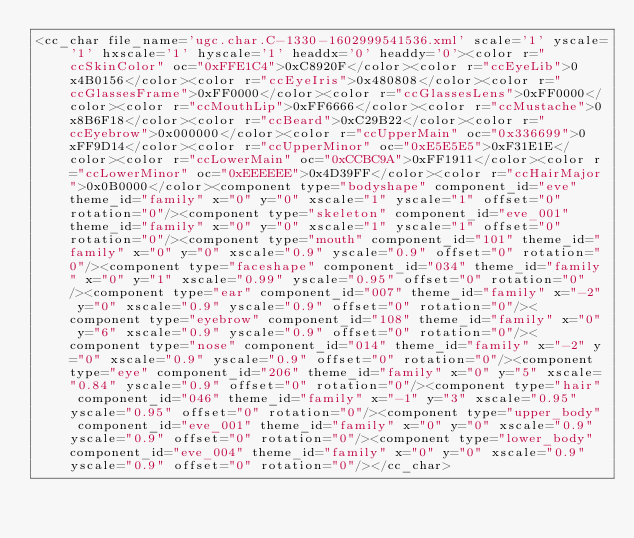Convert code to text. <code><loc_0><loc_0><loc_500><loc_500><_XML_><cc_char file_name='ugc.char.C-1330-1602999541536.xml' scale='1' yscale='1' hxscale='1' hyscale='1' headdx='0' headdy='0'><color r="ccSkinColor" oc="0xFFE1C4">0xC8920F</color><color r="ccEyeLib">0x4B0156</color><color r="ccEyeIris">0x480808</color><color r="ccGlassesFrame">0xFF0000</color><color r="ccGlassesLens">0xFF0000</color><color r="ccMouthLip">0xFF6666</color><color r="ccMustache">0x8B6F18</color><color r="ccBeard">0xC29B22</color><color r="ccEyebrow">0x000000</color><color r="ccUpperMain" oc="0x336699">0xFF9D14</color><color r="ccUpperMinor" oc="0xE5E5E5">0xF31E1E</color><color r="ccLowerMain" oc="0xCCBC9A">0xFF1911</color><color r="ccLowerMinor" oc="0xEEEEEE">0x4D39FF</color><color r="ccHairMajor">0x0B0000</color><component type="bodyshape" component_id="eve" theme_id="family" x="0" y="0" xscale="1" yscale="1" offset="0" rotation="0"/><component type="skeleton" component_id="eve_001" theme_id="family" x="0" y="0" xscale="1" yscale="1" offset="0" rotation="0"/><component type="mouth" component_id="101" theme_id="family" x="0" y="0" xscale="0.9" yscale="0.9" offset="0" rotation="0"/><component type="faceshape" component_id="034" theme_id="family" x="0" y="1" xscale="0.99" yscale="0.95" offset="0" rotation="0"/><component type="ear" component_id="007" theme_id="family" x="-2" y="0" xscale="0.9" yscale="0.9" offset="0" rotation="0"/><component type="eyebrow" component_id="108" theme_id="family" x="0" y="6" xscale="0.9" yscale="0.9" offset="0" rotation="0"/><component type="nose" component_id="014" theme_id="family" x="-2" y="0" xscale="0.9" yscale="0.9" offset="0" rotation="0"/><component type="eye" component_id="206" theme_id="family" x="0" y="5" xscale="0.84" yscale="0.9" offset="0" rotation="0"/><component type="hair" component_id="046" theme_id="family" x="-1" y="3" xscale="0.95" yscale="0.95" offset="0" rotation="0"/><component type="upper_body" component_id="eve_001" theme_id="family" x="0" y="0" xscale="0.9" yscale="0.9" offset="0" rotation="0"/><component type="lower_body" component_id="eve_004" theme_id="family" x="0" y="0" xscale="0.9" yscale="0.9" offset="0" rotation="0"/></cc_char></code> 